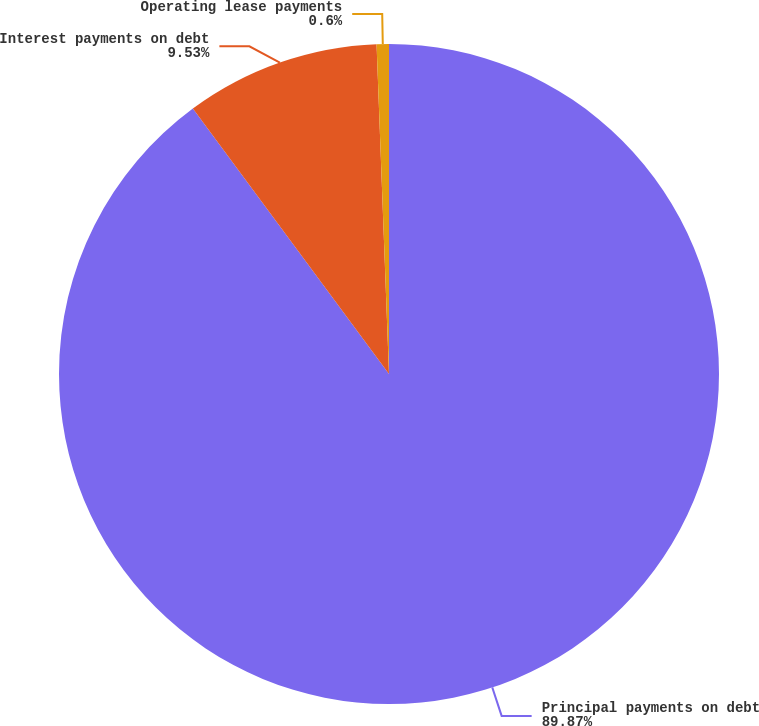<chart> <loc_0><loc_0><loc_500><loc_500><pie_chart><fcel>Principal payments on debt<fcel>Interest payments on debt<fcel>Operating lease payments<nl><fcel>89.87%<fcel>9.53%<fcel>0.6%<nl></chart> 